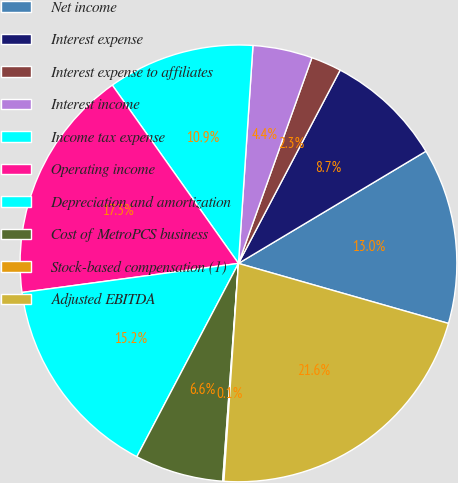<chart> <loc_0><loc_0><loc_500><loc_500><pie_chart><fcel>Net income<fcel>Interest expense<fcel>Interest expense to affiliates<fcel>Interest income<fcel>Income tax expense<fcel>Operating income<fcel>Depreciation and amortization<fcel>Cost of MetroPCS business<fcel>Stock-based compensation (1)<fcel>Adjusted EBITDA<nl><fcel>13.01%<fcel>8.71%<fcel>2.25%<fcel>4.4%<fcel>10.86%<fcel>17.32%<fcel>15.17%<fcel>6.55%<fcel>0.09%<fcel>21.63%<nl></chart> 